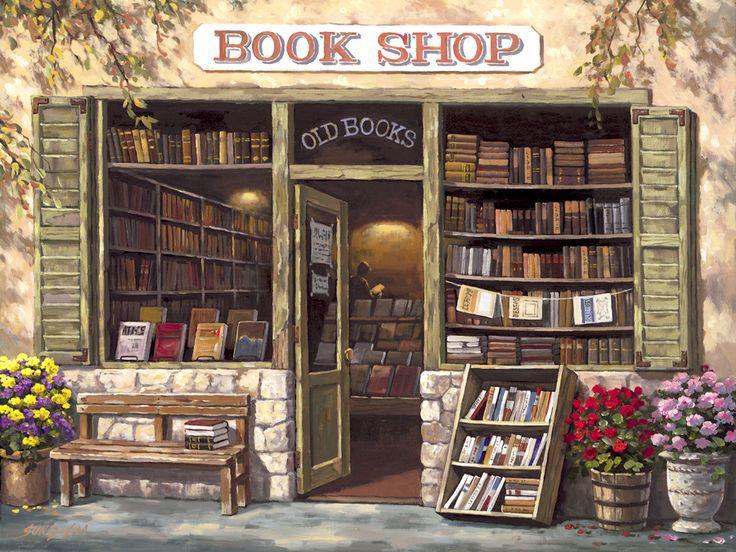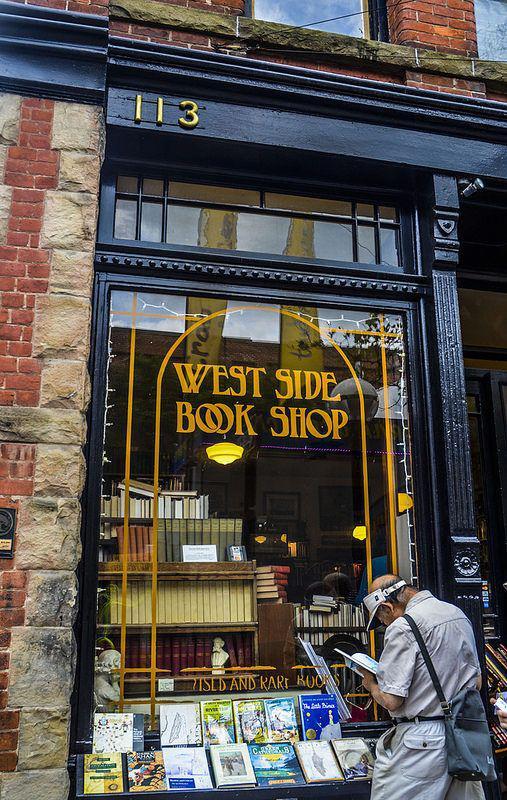The first image is the image on the left, the second image is the image on the right. Given the left and right images, does the statement "One storefront has light stone bordering around wood that is painted navy blue." hold true? Answer yes or no. Yes. The first image is the image on the left, the second image is the image on the right. Considering the images on both sides, is "There are at least two cardboard boxes of books on the pavement outside the book shop." valid? Answer yes or no. No. 